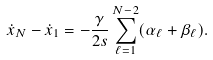<formula> <loc_0><loc_0><loc_500><loc_500>\dot { x } _ { N } - \dot { x } _ { 1 } = - \frac { \gamma } { 2 s } \sum _ { \ell = 1 } ^ { N - 2 } ( \alpha _ { \ell } + \beta _ { \ell } ) .</formula> 